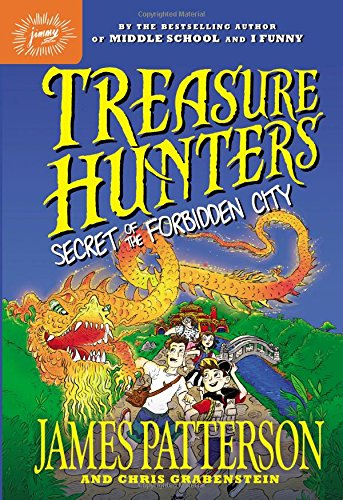Who is the author of this book?
Answer the question using a single word or phrase. James Patterson What is the title of this book? Treasure Hunters: Secret of the Forbidden City What type of book is this? Mystery, Thriller & Suspense Is this book related to Mystery, Thriller & Suspense? Yes Is this book related to Science & Math? No 